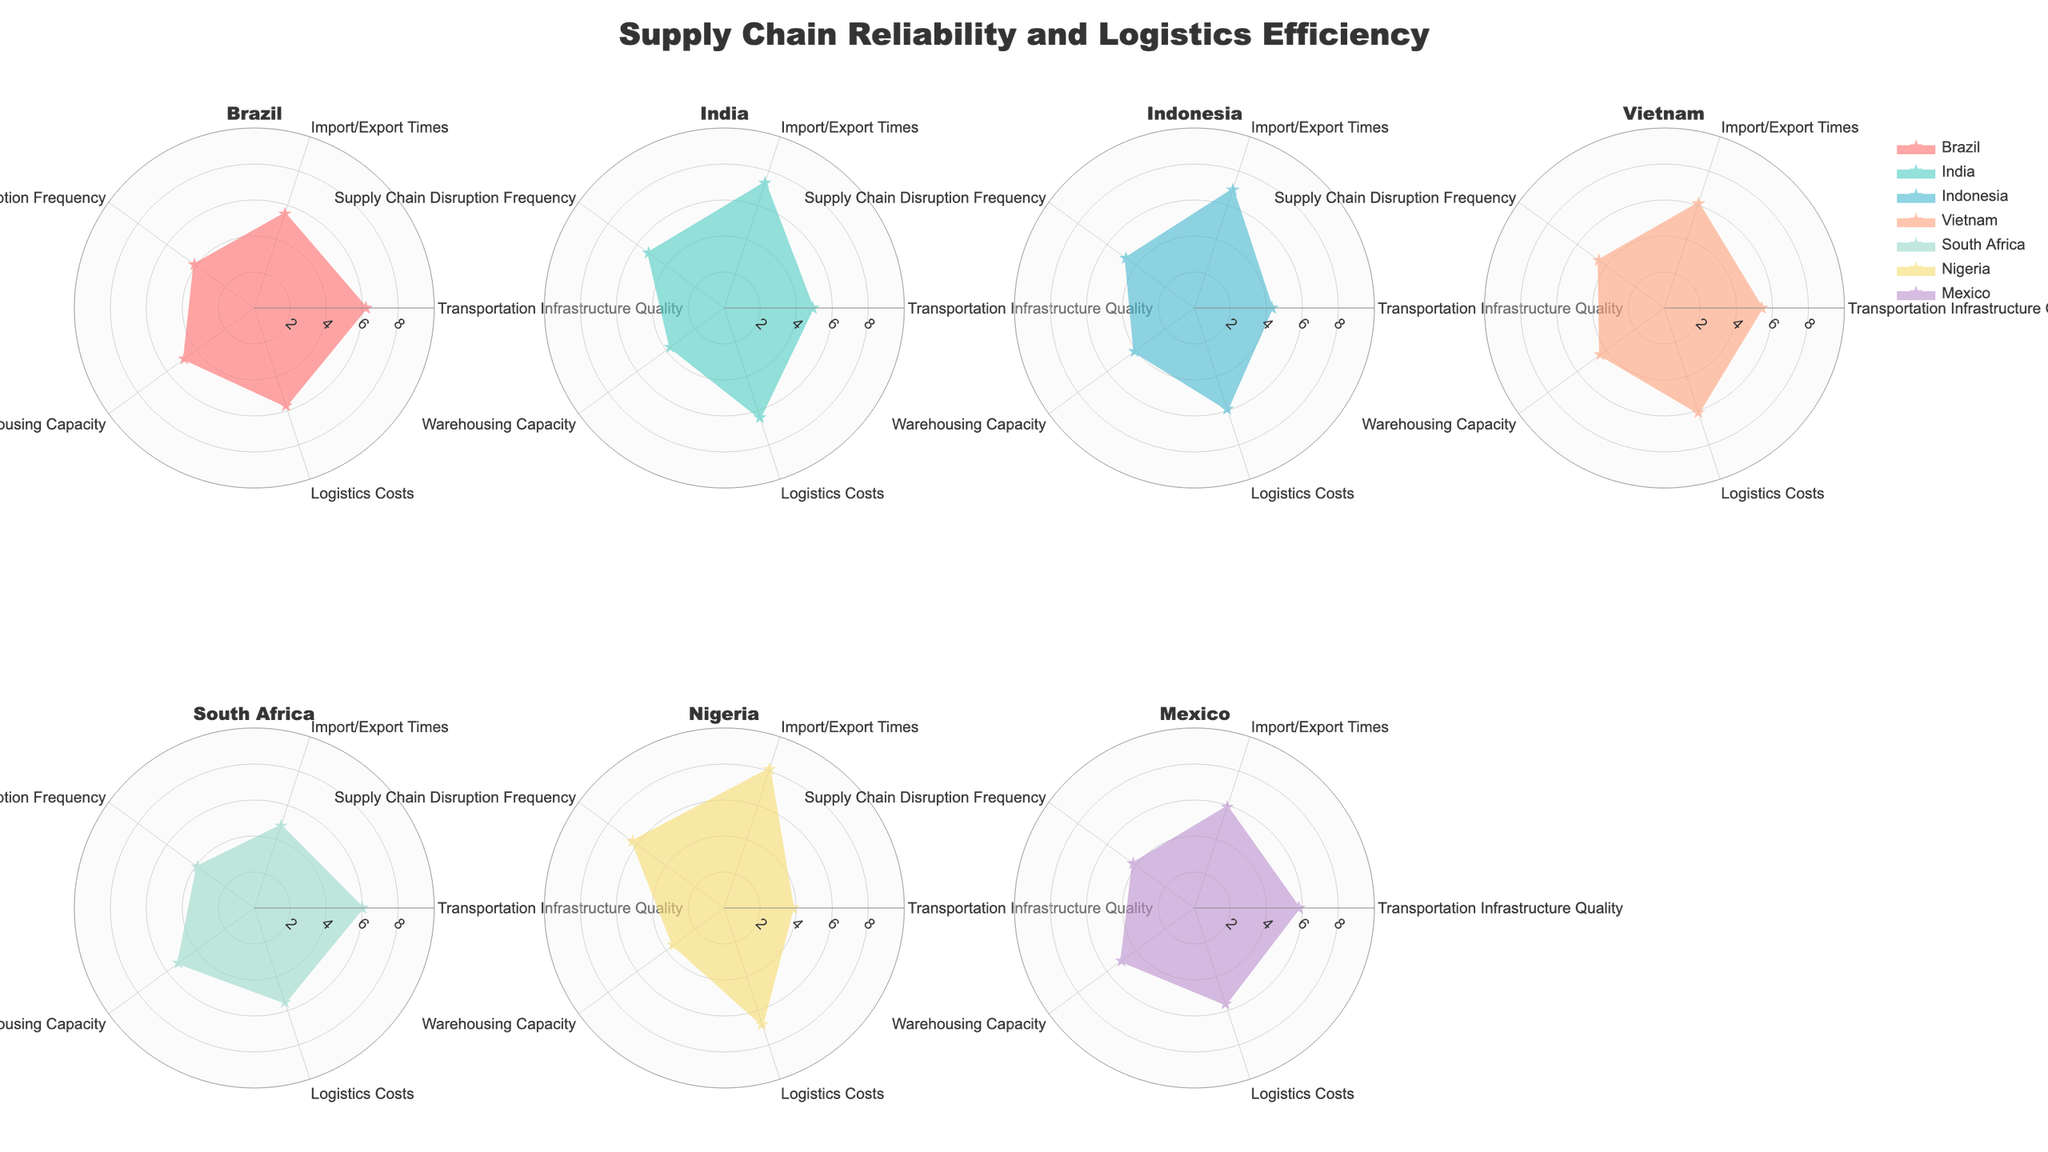What's the title of the chart? The title of the chart is clearly stated at the top.
Answer: Supply Chain Reliability and Logistics Efficiency What is the range of values on the radial axis? The radial axis has labels that show values ranging from 0 to 10, and tick marks at 2, 4, 6, and 8.
Answer: 0 to 10 Which country has the highest logistics costs? The radar chart reveals the logistics costs for each country; Nigeria has the highest value with logistics costs clearly labeled.
Answer: Nigeria How does India rank in terms of transportation infrastructure quality compared to other countries? By comparing India’s value (4.9) for transportation infrastructure quality against other countries on their respective radar plots, it is evident that India ranks lower than Brazil, Vietnam, and South Africa but higher than Indonesia and Nigeria.
Answer: Mid-range Which country has the lowest import/export times? By inspecting the radar chart segments for import/export times, South Africa, with a value of 4.8, has the lowest import/export times.
Answer: South Africa What is the average warehousing capacity for Brazil and Mexico? Brazil has a warehousing capacity of 4.8, and Mexico has a warehousing capacity of 5.0. Averaging these values: (4.8 + 5.0) / 2 = 4.9.
Answer: 4.9 Compare Indonesia and Vietnam in terms of supply chain disruption frequency. Which country performs better? By looking at the radar charts for both countries, Vietnam has a supply chain disruption frequency of 4.5, while Indonesia has a slightly higher value of 4.7. Lower values are better, so Vietnam performs better in this regard.
Answer: Vietnam What’s the overall warehousing capacity of South Africa compared to Nigeria? Comparing the radar charts of these countries, South Africa has a warehousing capacity of 5.2 while Nigeria has a lower value of 3.5. South Africa has a higher warehousing capacity.
Answer: South Africa Which two countries have the closest values for transportation infrastructure quality? By comparing segments on the radar charts, Brazil (6.2) and South Africa (6.0) have the closest values for transportation infrastructure quality.
Answer: Brazil and South Africa 